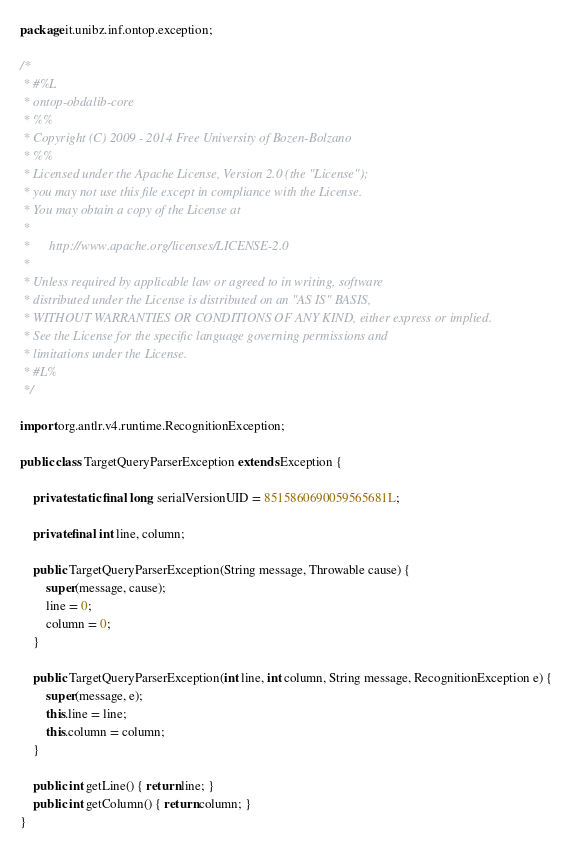Convert code to text. <code><loc_0><loc_0><loc_500><loc_500><_Java_>package it.unibz.inf.ontop.exception;

/*
 * #%L
 * ontop-obdalib-core
 * %%
 * Copyright (C) 2009 - 2014 Free University of Bozen-Bolzano
 * %%
 * Licensed under the Apache License, Version 2.0 (the "License");
 * you may not use this file except in compliance with the License.
 * You may obtain a copy of the License at
 * 
 *      http://www.apache.org/licenses/LICENSE-2.0
 * 
 * Unless required by applicable law or agreed to in writing, software
 * distributed under the License is distributed on an "AS IS" BASIS,
 * WITHOUT WARRANTIES OR CONDITIONS OF ANY KIND, either express or implied.
 * See the License for the specific language governing permissions and
 * limitations under the License.
 * #L%
 */

import org.antlr.v4.runtime.RecognitionException;

public class TargetQueryParserException extends Exception {
	
	private static final long serialVersionUID = 8515860690059565681L;

	private final int line, column;

	public TargetQueryParserException(String message, Throwable cause) {
		super(message, cause);
		line = 0;
		column = 0;
	}

	public TargetQueryParserException(int line, int column, String message, RecognitionException e) {
		super(message, e);
		this.line = line;
		this.column = column;
	}

	public int getLine() { return line; }
	public int getColumn() { return column; }
}
</code> 